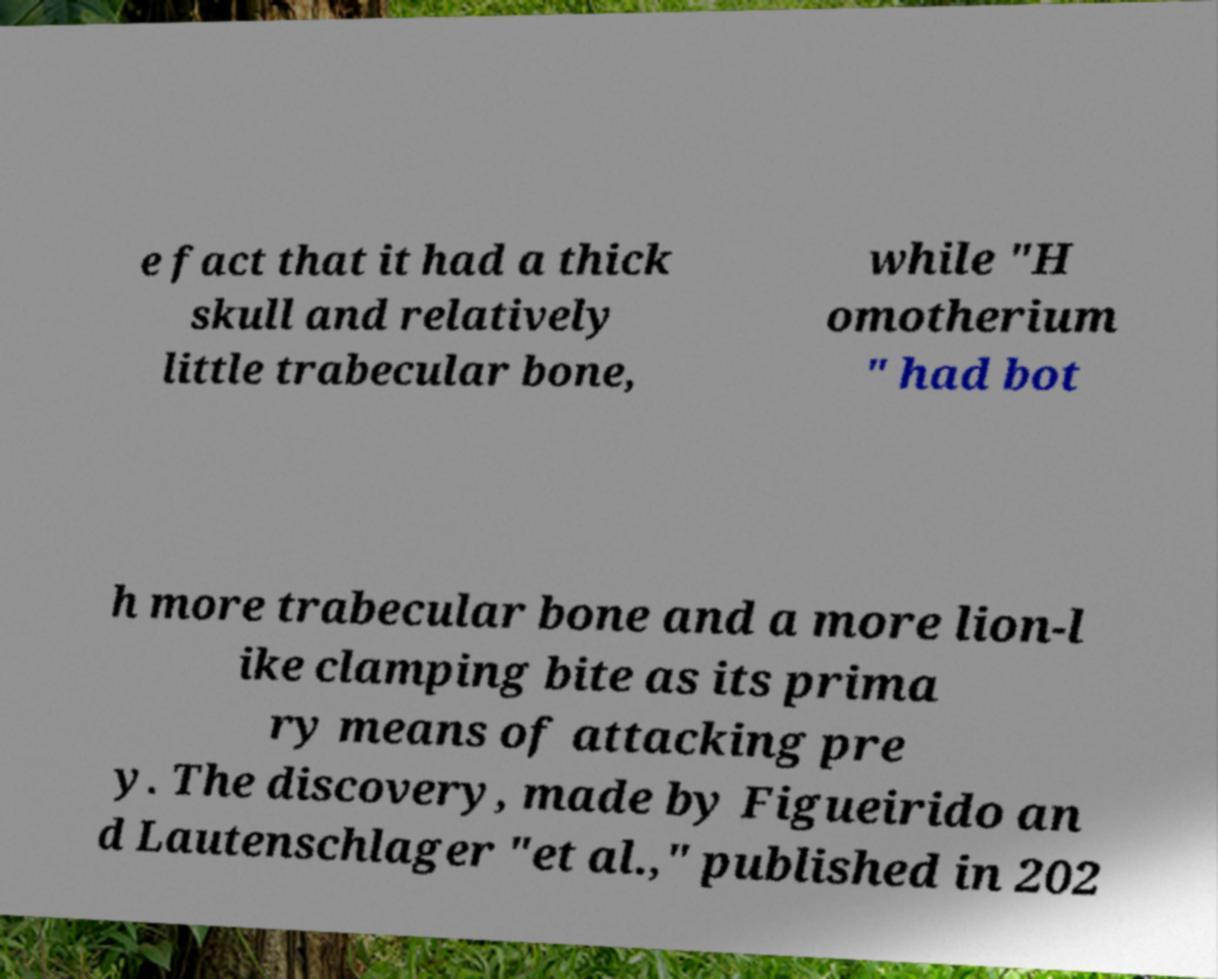Please read and relay the text visible in this image. What does it say? e fact that it had a thick skull and relatively little trabecular bone, while "H omotherium " had bot h more trabecular bone and a more lion-l ike clamping bite as its prima ry means of attacking pre y. The discovery, made by Figueirido an d Lautenschlager "et al.," published in 202 